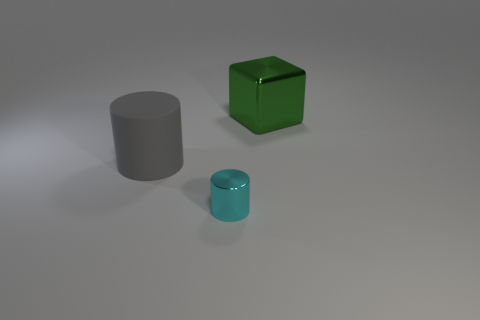The object on the right side of the shiny cylinder has what shape?
Provide a succinct answer. Cube. Are the big gray thing and the big object on the right side of the cyan object made of the same material?
Make the answer very short. No. Are any green things visible?
Offer a very short reply. Yes. There is a metallic thing in front of the large object that is left of the tiny cyan metal thing; is there a cyan thing in front of it?
Provide a succinct answer. No. How many big objects are either rubber cylinders or green metal blocks?
Your answer should be very brief. 2. The thing that is the same size as the gray cylinder is what color?
Offer a very short reply. Green. There is a rubber thing; how many cyan metallic things are behind it?
Provide a succinct answer. 0. Is there another big cylinder that has the same material as the cyan cylinder?
Ensure brevity in your answer.  No. The shiny object that is in front of the green shiny object is what color?
Your answer should be very brief. Cyan. Is the number of cubes that are to the left of the big gray rubber thing the same as the number of cylinders right of the small thing?
Offer a very short reply. Yes. 